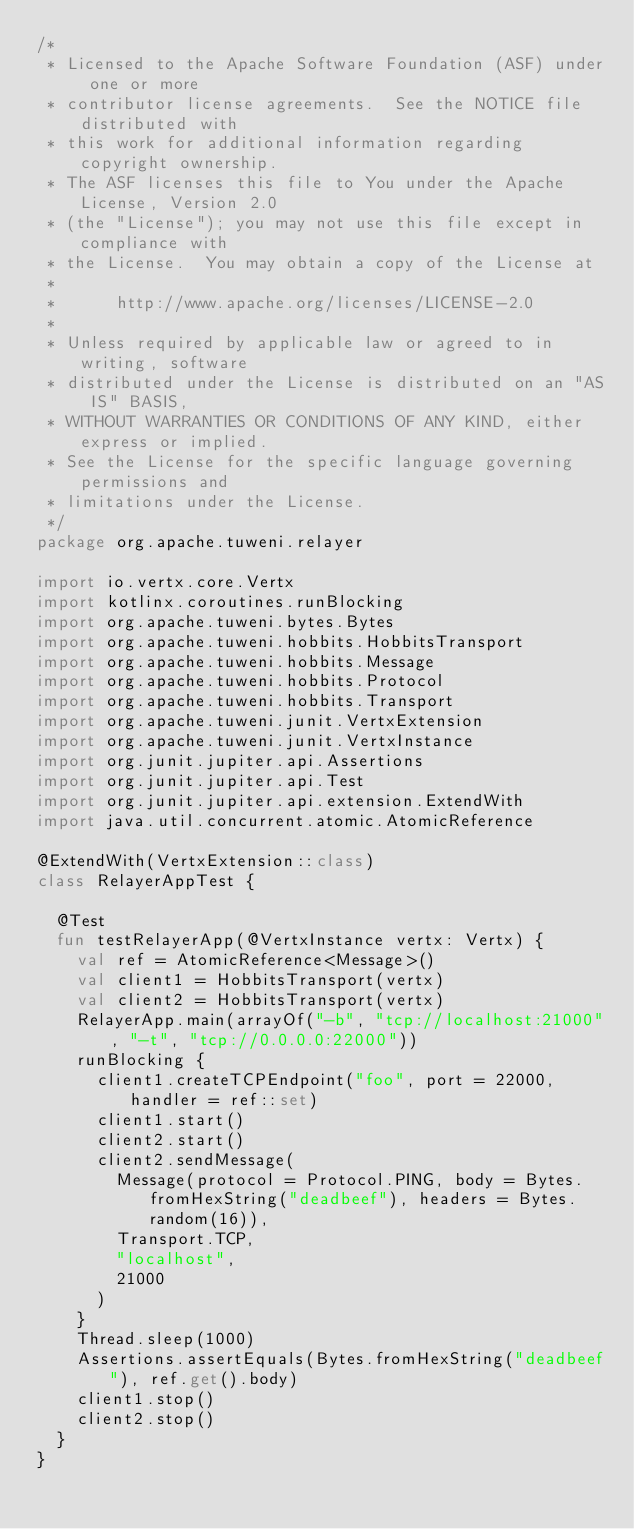<code> <loc_0><loc_0><loc_500><loc_500><_Kotlin_>/*
 * Licensed to the Apache Software Foundation (ASF) under one or more
 * contributor license agreements.  See the NOTICE file distributed with
 * this work for additional information regarding copyright ownership.
 * The ASF licenses this file to You under the Apache License, Version 2.0
 * (the "License"); you may not use this file except in compliance with
 * the License.  You may obtain a copy of the License at
 *
 *      http://www.apache.org/licenses/LICENSE-2.0
 *
 * Unless required by applicable law or agreed to in writing, software
 * distributed under the License is distributed on an "AS IS" BASIS,
 * WITHOUT WARRANTIES OR CONDITIONS OF ANY KIND, either express or implied.
 * See the License for the specific language governing permissions and
 * limitations under the License.
 */
package org.apache.tuweni.relayer

import io.vertx.core.Vertx
import kotlinx.coroutines.runBlocking
import org.apache.tuweni.bytes.Bytes
import org.apache.tuweni.hobbits.HobbitsTransport
import org.apache.tuweni.hobbits.Message
import org.apache.tuweni.hobbits.Protocol
import org.apache.tuweni.hobbits.Transport
import org.apache.tuweni.junit.VertxExtension
import org.apache.tuweni.junit.VertxInstance
import org.junit.jupiter.api.Assertions
import org.junit.jupiter.api.Test
import org.junit.jupiter.api.extension.ExtendWith
import java.util.concurrent.atomic.AtomicReference

@ExtendWith(VertxExtension::class)
class RelayerAppTest {

  @Test
  fun testRelayerApp(@VertxInstance vertx: Vertx) {
    val ref = AtomicReference<Message>()
    val client1 = HobbitsTransport(vertx)
    val client2 = HobbitsTransport(vertx)
    RelayerApp.main(arrayOf("-b", "tcp://localhost:21000", "-t", "tcp://0.0.0.0:22000"))
    runBlocking {
      client1.createTCPEndpoint("foo", port = 22000, handler = ref::set)
      client1.start()
      client2.start()
      client2.sendMessage(
        Message(protocol = Protocol.PING, body = Bytes.fromHexString("deadbeef"), headers = Bytes.random(16)),
        Transport.TCP,
        "localhost",
        21000
      )
    }
    Thread.sleep(1000)
    Assertions.assertEquals(Bytes.fromHexString("deadbeef"), ref.get().body)
    client1.stop()
    client2.stop()
  }
}
</code> 